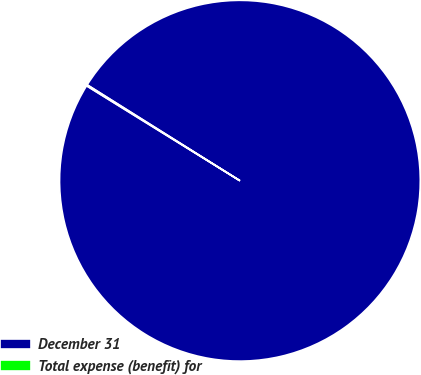Convert chart. <chart><loc_0><loc_0><loc_500><loc_500><pie_chart><fcel>December 31<fcel>Total expense (benefit) for<nl><fcel>99.9%<fcel>0.1%<nl></chart> 